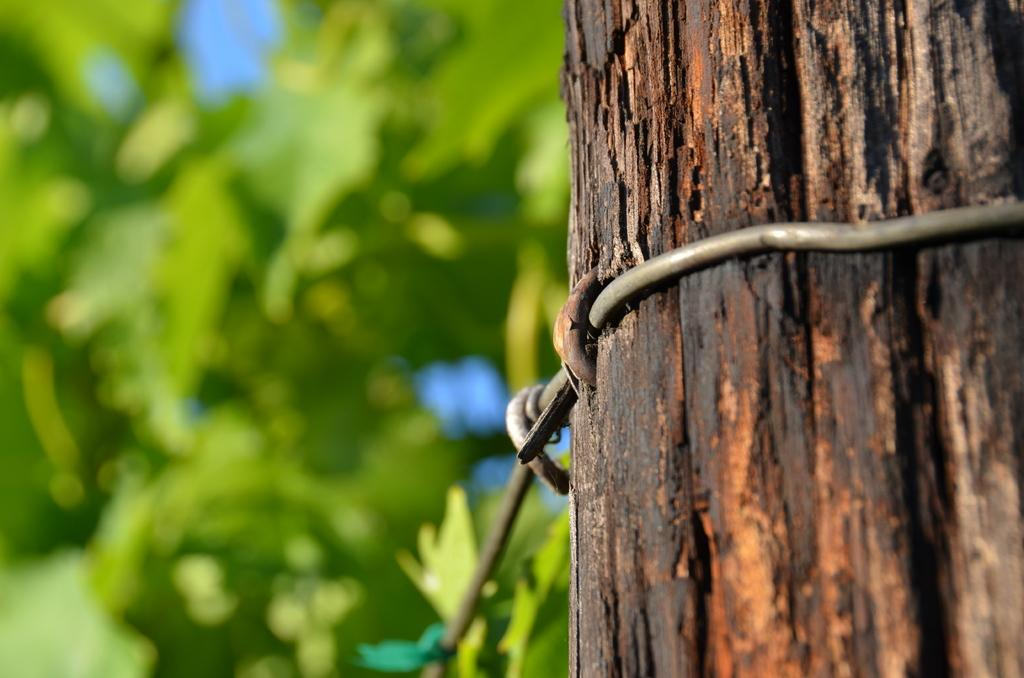What is the main object in the image? There is a pole in the image. What is unique about the pole? The pole has metal wires around it. What can be seen in the distance in the image? There are trees in the background of the image. How many brothers are on the boat in the image? There is no boat or brothers present in the image. 